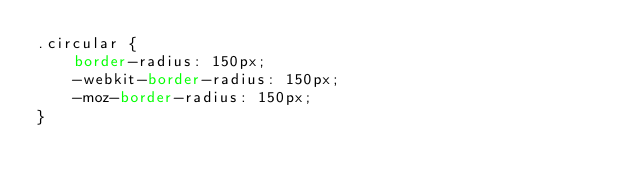Convert code to text. <code><loc_0><loc_0><loc_500><loc_500><_CSS_>.circular {
	border-radius: 150px;
	-webkit-border-radius: 150px;
	-moz-border-radius: 150px;
}</code> 